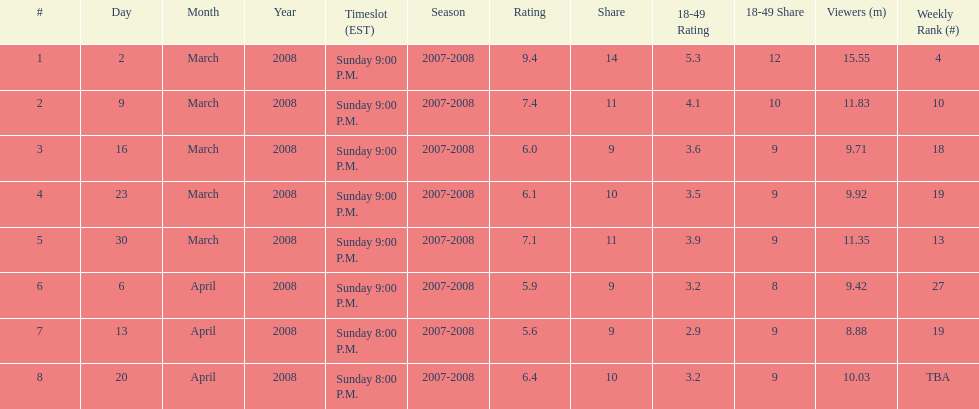What episode had the highest rating? March 2, 2008. 